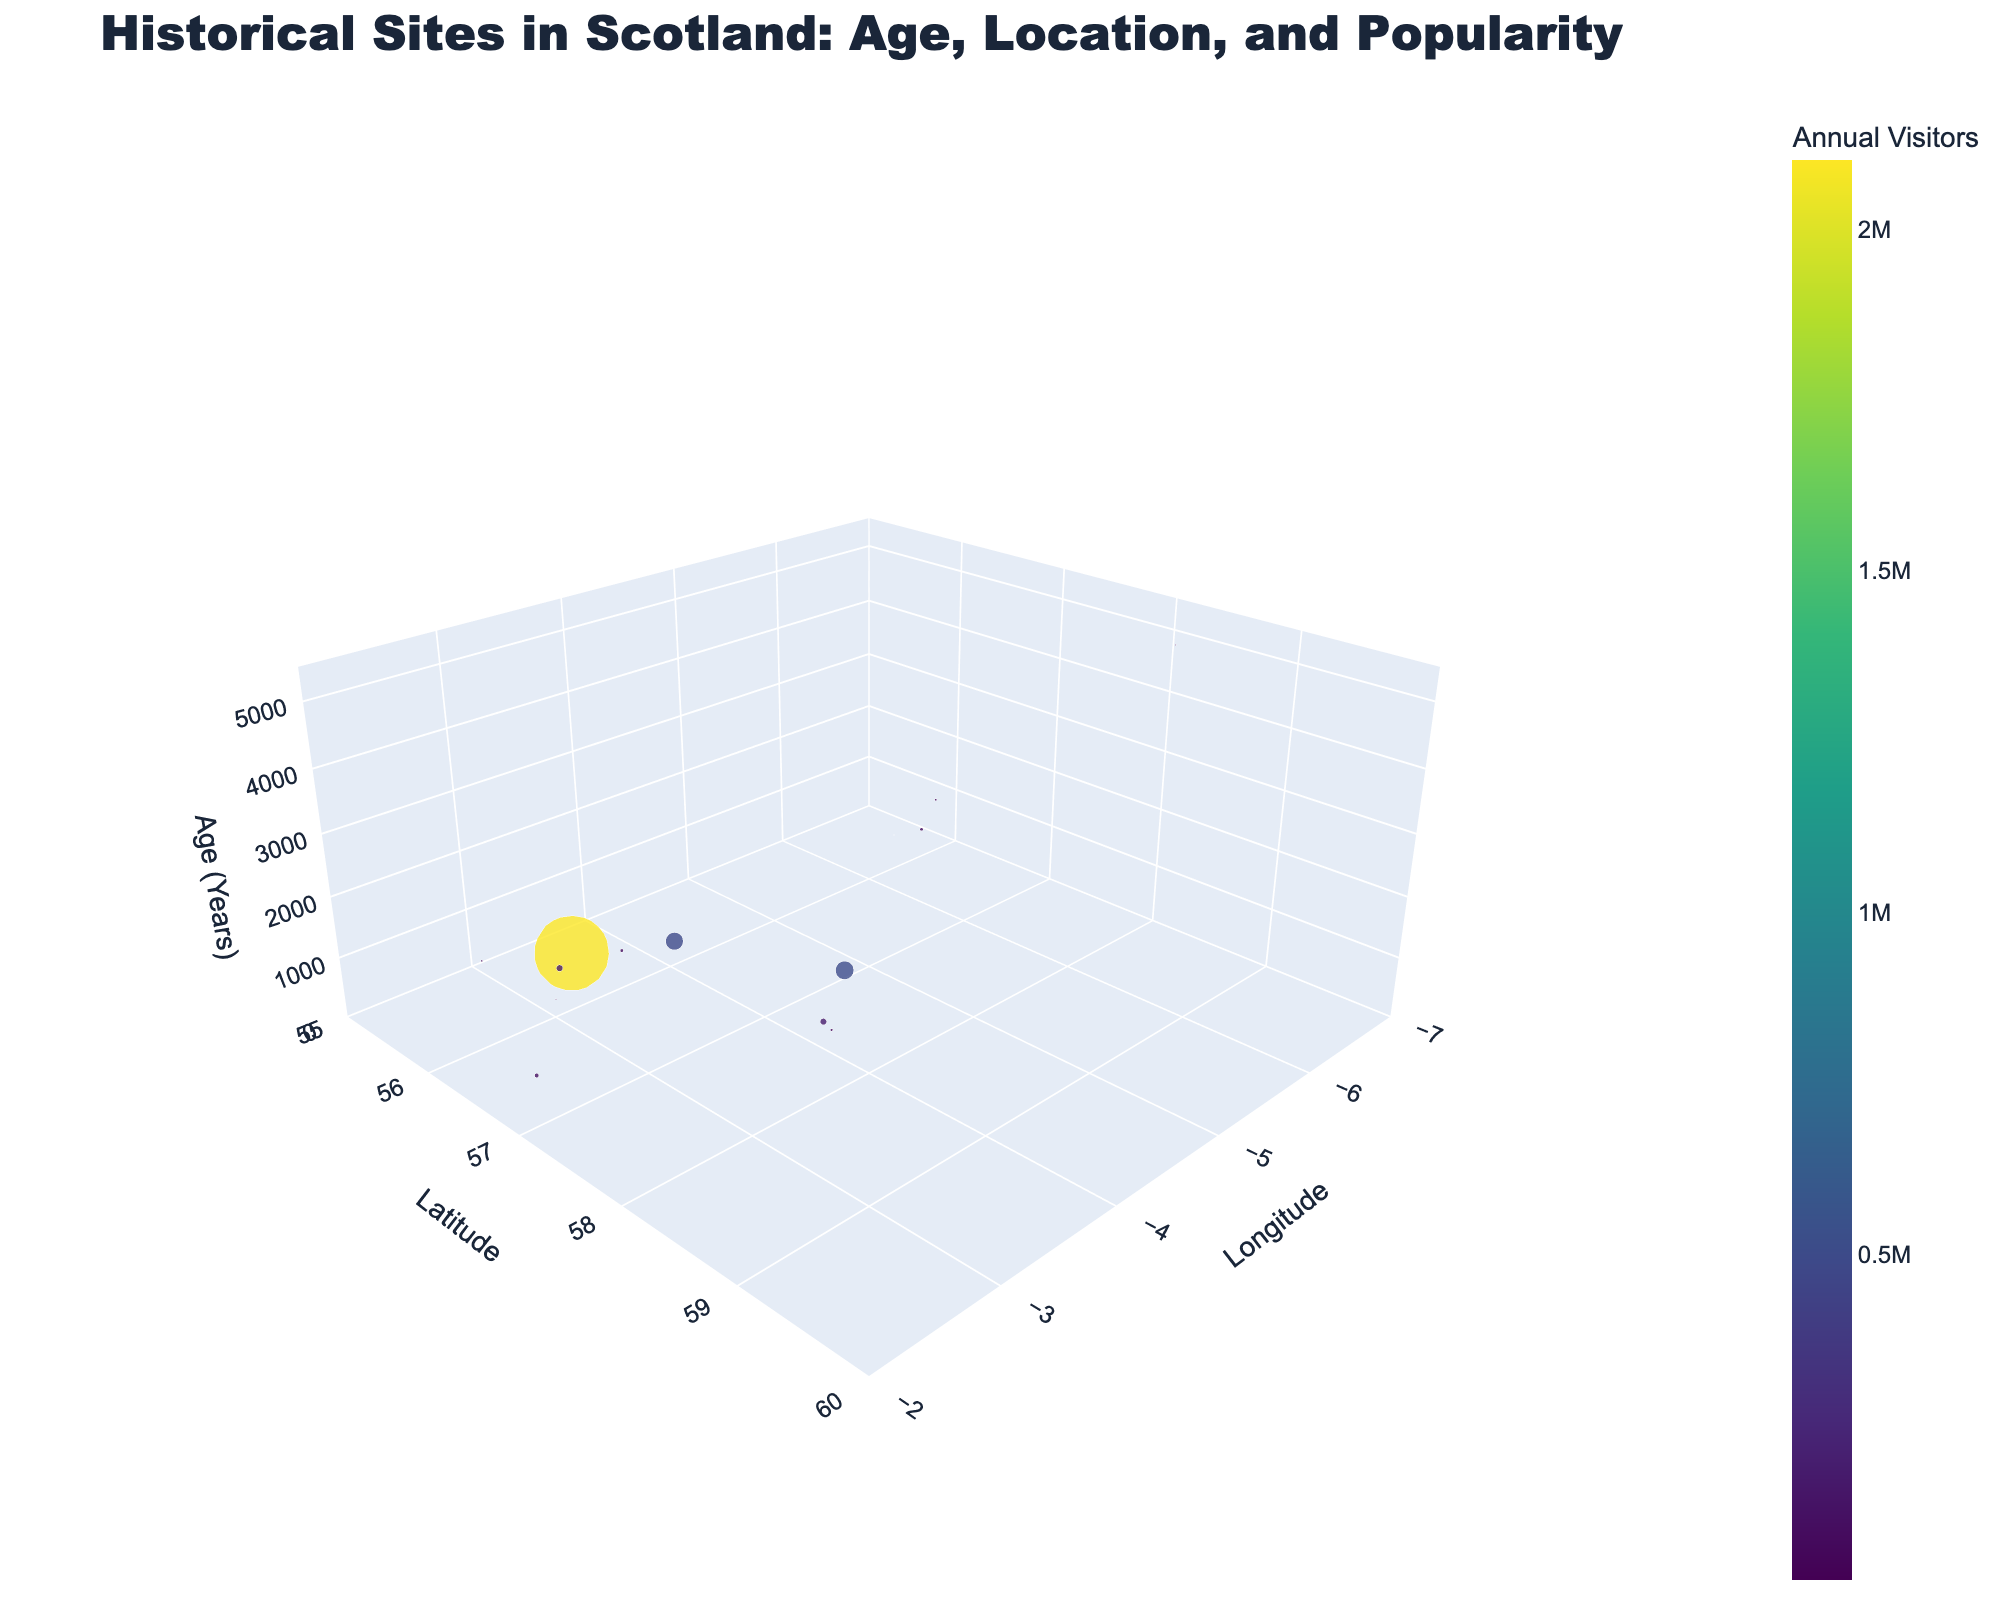What is the title of the 3D scatter plot? The title is prominently displayed at the top of the figure.
Answer: Historical Sites in Scotland: Age, Location, and Popularity Which site has the highest number of annual visitors? By examining the size and color intensity of the markers, the largest and most brightly colored marker represents the highest annual visitors.
Answer: Edinburgh Castle How many sites have an age greater than 1000 years? Identifying markers on the z-axis (Age) that are positioned above 1000 years, we count the corresponding data points.
Answer: 5 sites Which sites are located further north: Skara Brae or Rosslyn Chapel? Comparing the latitude values of both sites, the site with the higher latitude is further north.
Answer: Skara Brae What is the age of the site located at latitude 56.3352 and longitude -6.3912? By identifying the coordinates (56.3352, -6.3912), we find the corresponding data point and check the z-axis (Age) value.
Answer: 1450 years Which site is older: Urquhart Castle or Dunnottar Castle? Comparing the z-axis values (Age) for both sites, we can determine which one has a higher age value.
Answer: Urquhart Castle What is the average annual visitor count for sites older than 2000 years? First, identify the sites with an age greater than 2000 years and sum their annual visitors, then divide by the number of these sites. Average = (90000 + 40000 + 23000) / 3 = 51000
Answer: 51000 Which site is located west of 3 degrees longitude and has over 100,000 annual visitors? Filtering data points with a longitude less than -3 and an annual visitor count over 100,000 to identify the specific site(s).
Answer: Rosslyn Chapel What is the age difference between Melrose Abbey and Iona Abbey? Subtracting the age values of both sites to find the difference. Difference = 1450 - 850
Answer: 600 How many sites receive fewer than 100,000 annual visitors? Counting the sites with an annual visitor count below 100,000.
Answer: 8 